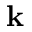<formula> <loc_0><loc_0><loc_500><loc_500>k</formula> 